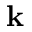<formula> <loc_0><loc_0><loc_500><loc_500>k</formula> 